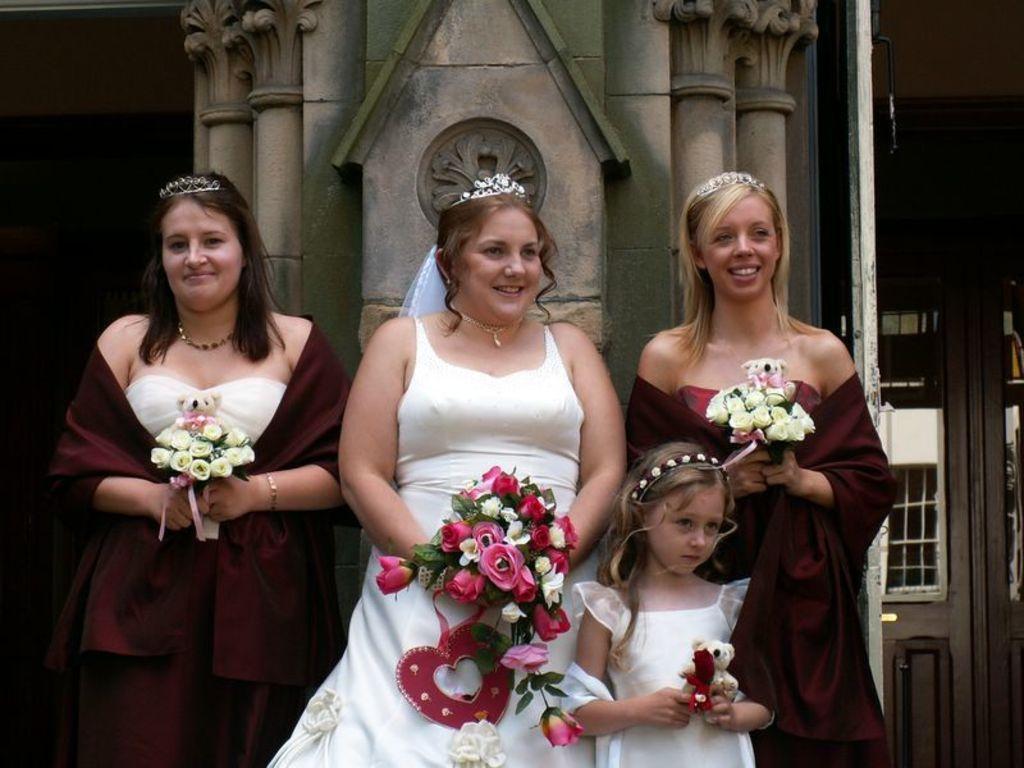Describe this image in one or two sentences. In this image we can see three woman standing holding the bouquets. In that two women are holding teddy bears. On the bottom of the image we can see a child standing beside them holding a teddy bear. On the backside we can see some pillars and a wall. 